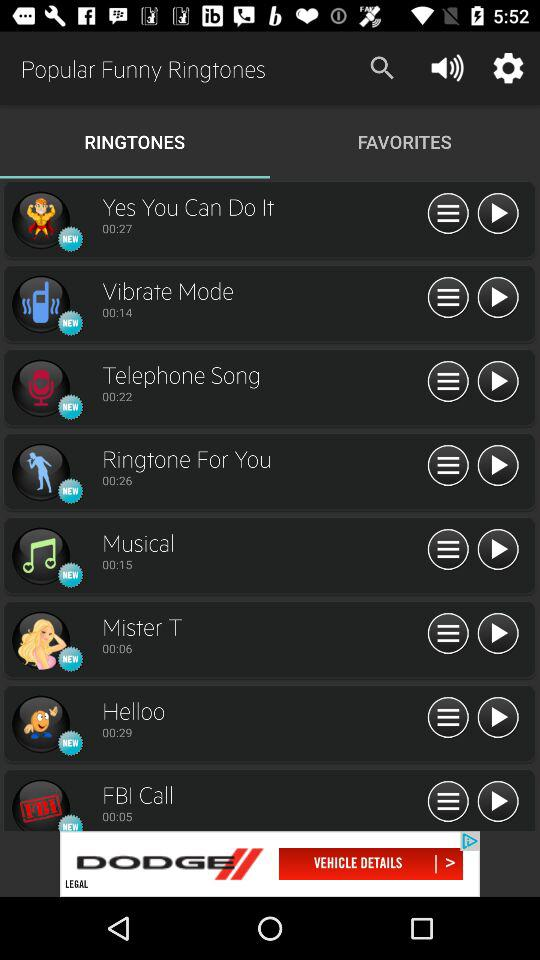What is the duration of the musical ringtone? The duration of the musical ringtone is 00:15. 